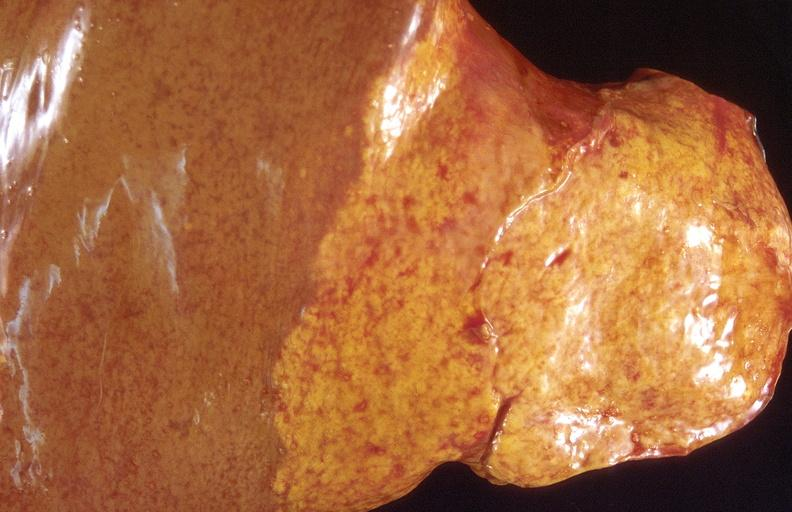what does this image show?
Answer the question using a single word or phrase. Cholangiocarcinoma 